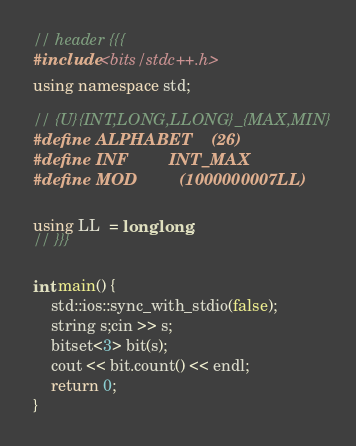Convert code to text. <code><loc_0><loc_0><loc_500><loc_500><_C++_>// header {{{
#include <bits/stdc++.h>
using namespace std;

// {U}{INT,LONG,LLONG}_{MAX,MIN}
#define ALPHABET    (26)
#define INF         INT_MAX
#define MOD         (1000000007LL)

using LL  = long long;
// }}}

int main() {
    std::ios::sync_with_stdio(false);
    string s;cin >> s;
    bitset<3> bit(s);
    cout << bit.count() << endl;
    return 0;
}
</code> 